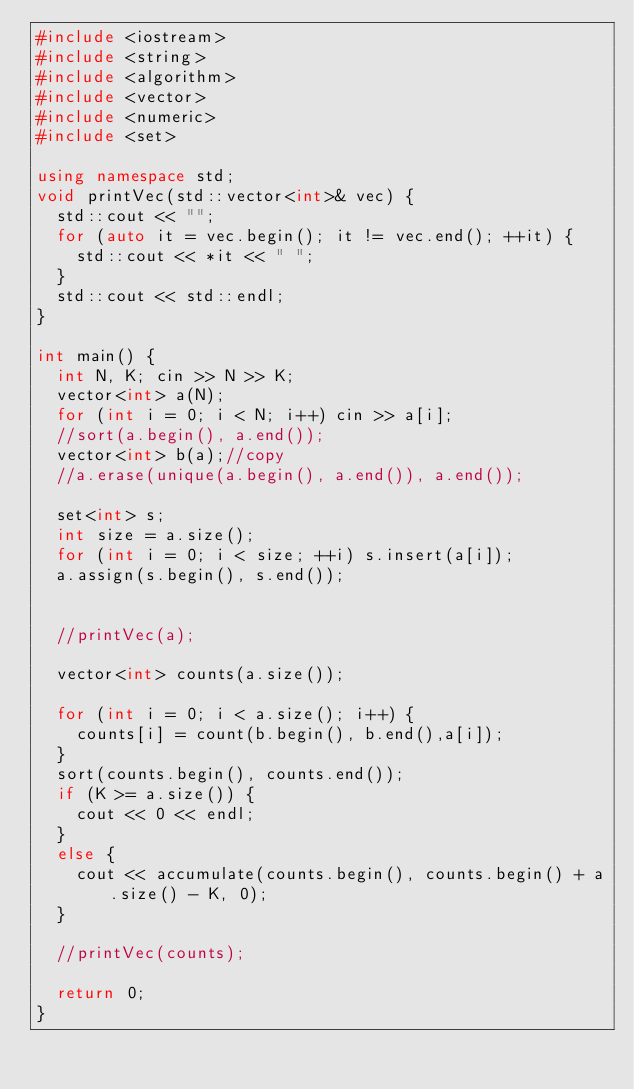Convert code to text. <code><loc_0><loc_0><loc_500><loc_500><_C++_>#include <iostream>
#include <string>
#include <algorithm>
#include <vector>
#include <numeric>
#include <set>

using namespace std;
void printVec(std::vector<int>& vec) {
	std::cout << "";
	for (auto it = vec.begin(); it != vec.end(); ++it) {
		std::cout << *it << " ";
	}
	std::cout << std::endl;
}

int main() {
	int N, K; cin >> N >> K;
	vector<int> a(N);
	for (int i = 0; i < N; i++) cin >> a[i];
	//sort(a.begin(), a.end());
	vector<int> b(a);//copy
	//a.erase(unique(a.begin(), a.end()), a.end());
	
	set<int> s;
	int size = a.size();
	for (int i = 0; i < size; ++i) s.insert(a[i]);
	a.assign(s.begin(), s.end());
	

	//printVec(a);

	vector<int> counts(a.size());

	for (int i = 0; i < a.size(); i++) {
		counts[i] = count(b.begin(), b.end(),a[i]);
	}
	sort(counts.begin(), counts.end());
	if (K >= a.size()) {
		cout << 0 << endl;
	}
	else {
		cout << accumulate(counts.begin(), counts.begin() + a.size() - K, 0);
	}
	
	//printVec(counts);

	return 0;
}</code> 